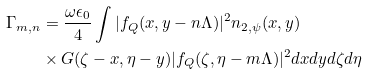Convert formula to latex. <formula><loc_0><loc_0><loc_500><loc_500>\Gamma _ { m , n } & = \frac { \omega \epsilon _ { 0 } } { 4 } \int | f _ { Q } ( x , y - n \Lambda ) | ^ { 2 } n _ { 2 , \psi } ( x , y ) \\ & \times G ( \zeta - x , \eta - y ) | f _ { Q } ( \zeta , \eta - m \Lambda ) | ^ { 2 } d x d y d \zeta d \eta</formula> 